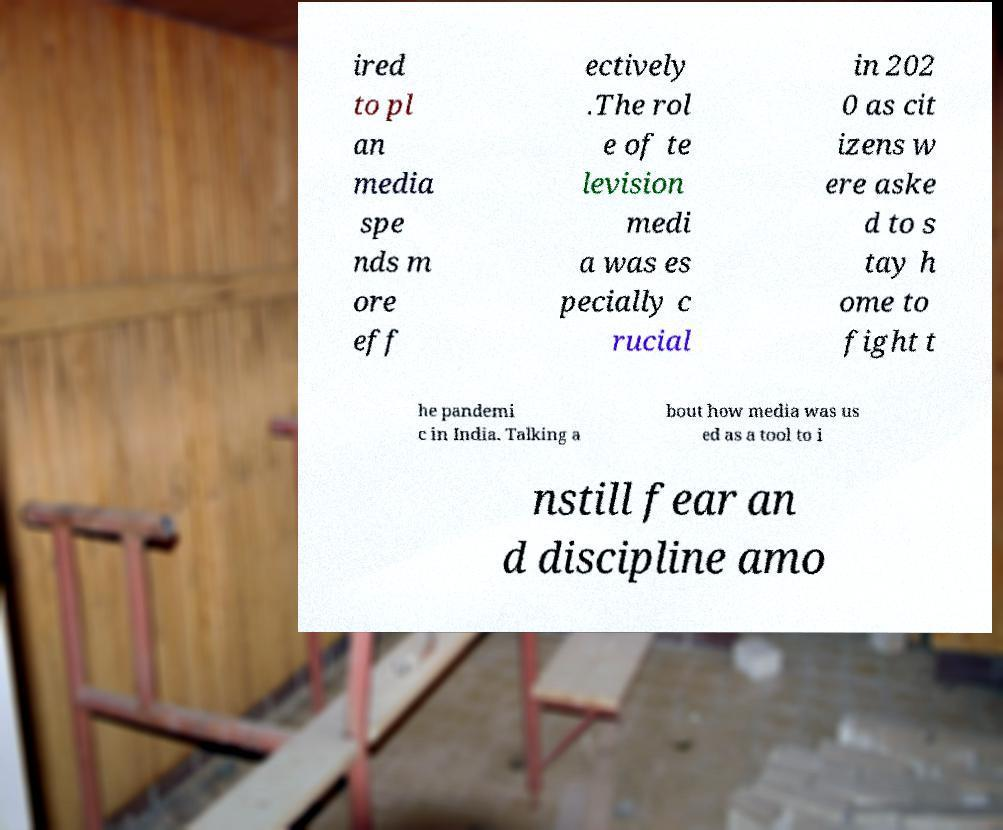What messages or text are displayed in this image? I need them in a readable, typed format. ired to pl an media spe nds m ore eff ectively .The rol e of te levision medi a was es pecially c rucial in 202 0 as cit izens w ere aske d to s tay h ome to fight t he pandemi c in India. Talking a bout how media was us ed as a tool to i nstill fear an d discipline amo 